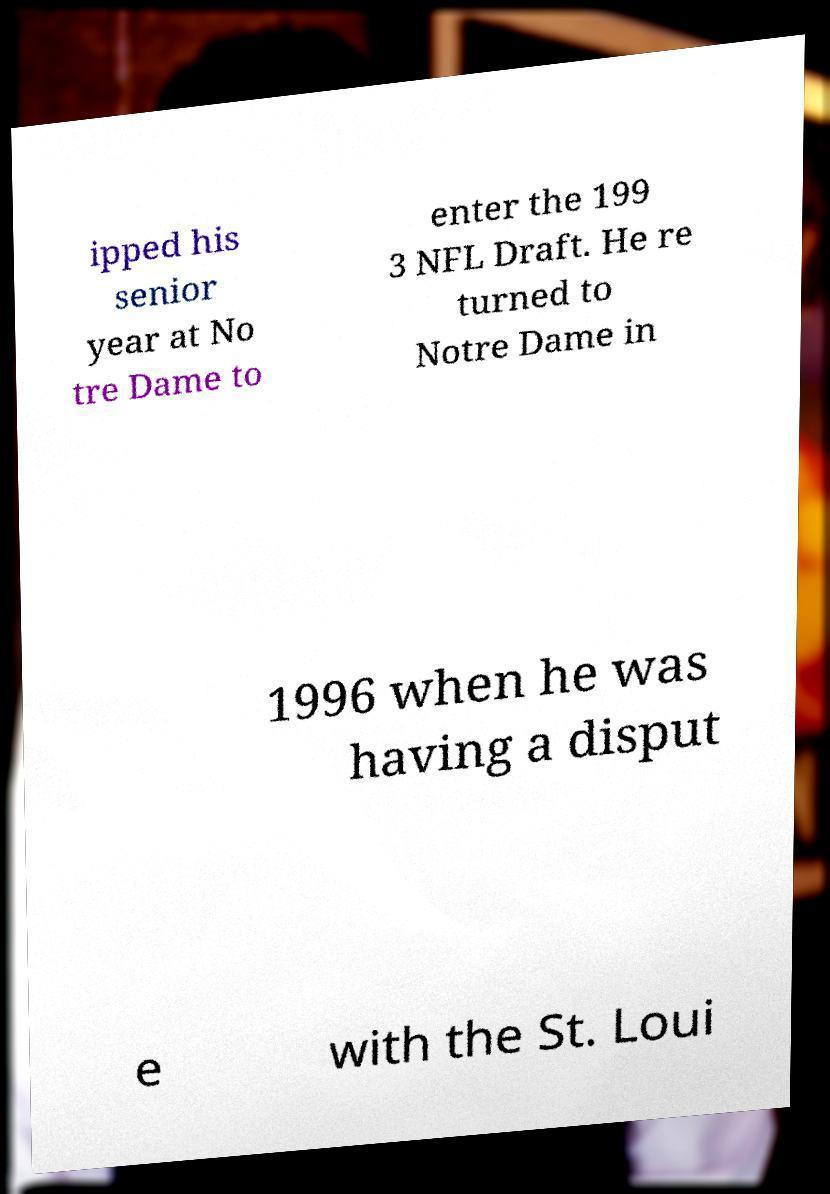There's text embedded in this image that I need extracted. Can you transcribe it verbatim? ipped his senior year at No tre Dame to enter the 199 3 NFL Draft. He re turned to Notre Dame in 1996 when he was having a disput e with the St. Loui 